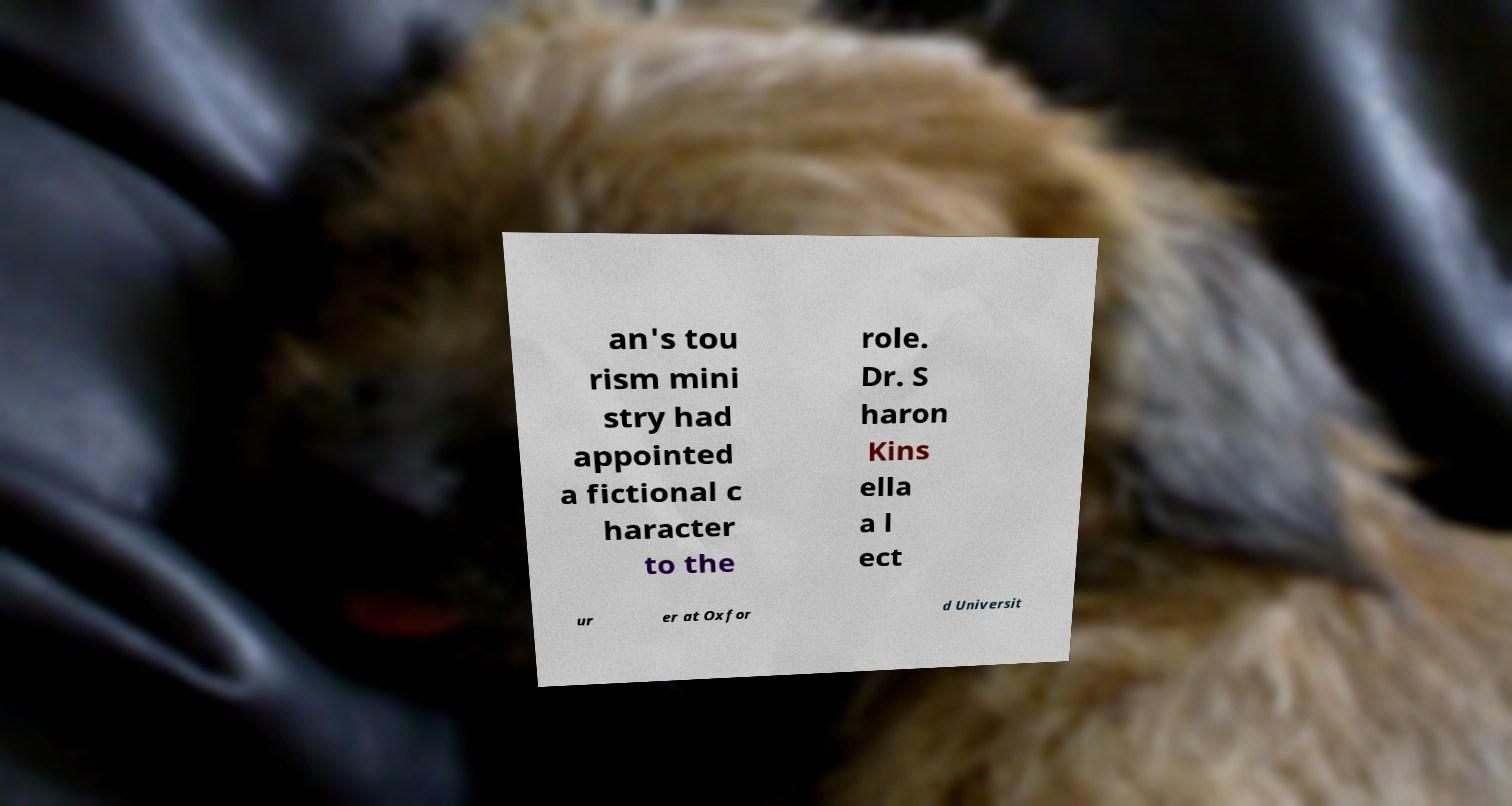Please read and relay the text visible in this image. What does it say? an's tou rism mini stry had appointed a fictional c haracter to the role. Dr. S haron Kins ella a l ect ur er at Oxfor d Universit 